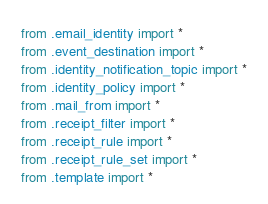<code> <loc_0><loc_0><loc_500><loc_500><_Python_>from .email_identity import *
from .event_destination import *
from .identity_notification_topic import *
from .identity_policy import *
from .mail_from import *
from .receipt_filter import *
from .receipt_rule import *
from .receipt_rule_set import *
from .template import *
</code> 